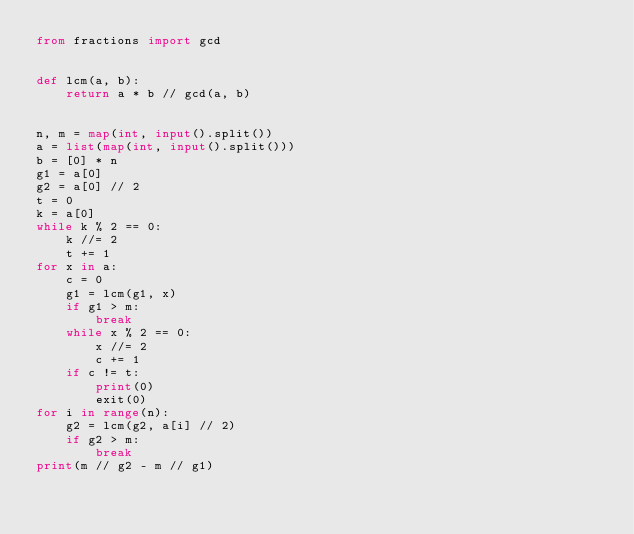Convert code to text. <code><loc_0><loc_0><loc_500><loc_500><_Python_>from fractions import gcd


def lcm(a, b):
    return a * b // gcd(a, b)


n, m = map(int, input().split())
a = list(map(int, input().split()))
b = [0] * n
g1 = a[0]
g2 = a[0] // 2
t = 0
k = a[0]
while k % 2 == 0:
    k //= 2
    t += 1
for x in a:
    c = 0
    g1 = lcm(g1, x)
    if g1 > m:
        break
    while x % 2 == 0:
        x //= 2
        c += 1
    if c != t:
        print(0)
        exit(0)
for i in range(n):
    g2 = lcm(g2, a[i] // 2)
    if g2 > m:
        break
print(m // g2 - m // g1)
</code> 